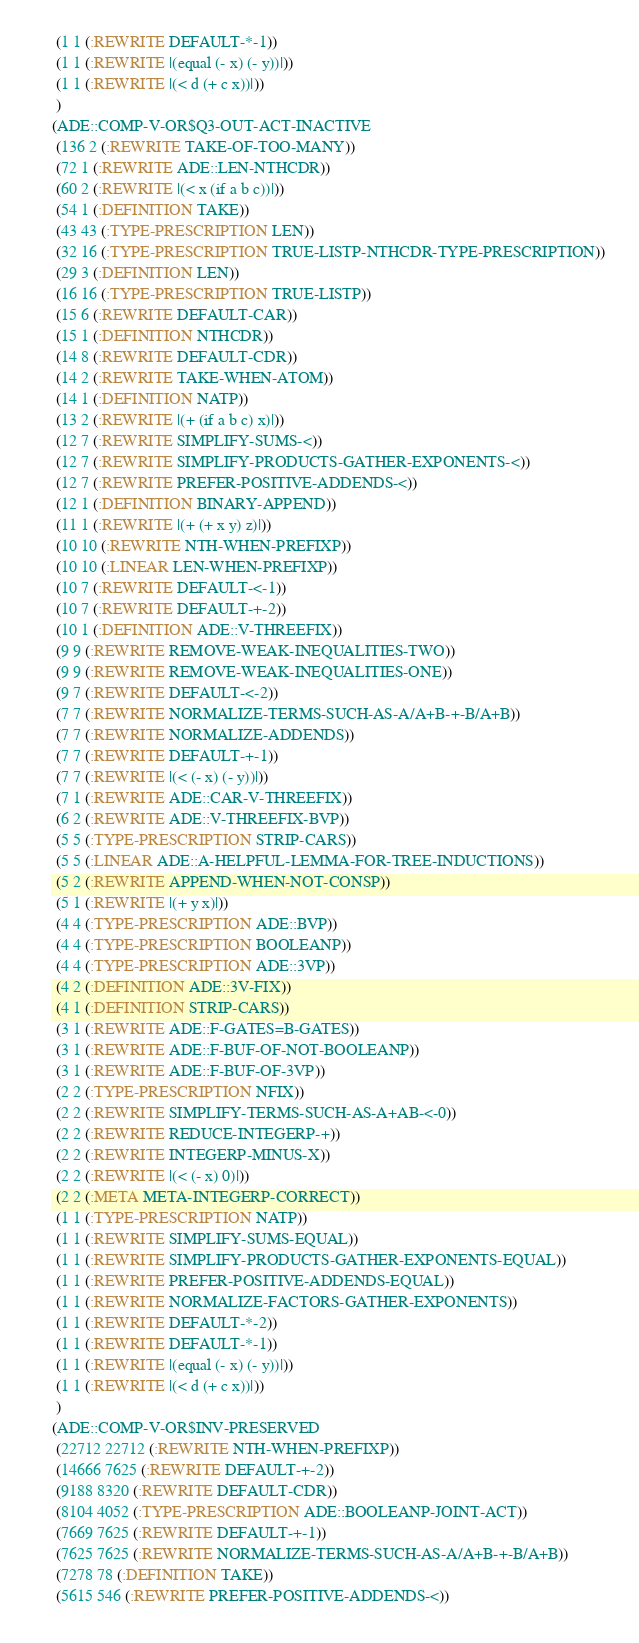<code> <loc_0><loc_0><loc_500><loc_500><_Lisp_> (1 1 (:REWRITE DEFAULT-*-1))
 (1 1 (:REWRITE |(equal (- x) (- y))|))
 (1 1 (:REWRITE |(< d (+ c x))|))
 )
(ADE::COMP-V-OR$Q3-OUT-ACT-INACTIVE
 (136 2 (:REWRITE TAKE-OF-TOO-MANY))
 (72 1 (:REWRITE ADE::LEN-NTHCDR))
 (60 2 (:REWRITE |(< x (if a b c))|))
 (54 1 (:DEFINITION TAKE))
 (43 43 (:TYPE-PRESCRIPTION LEN))
 (32 16 (:TYPE-PRESCRIPTION TRUE-LISTP-NTHCDR-TYPE-PRESCRIPTION))
 (29 3 (:DEFINITION LEN))
 (16 16 (:TYPE-PRESCRIPTION TRUE-LISTP))
 (15 6 (:REWRITE DEFAULT-CAR))
 (15 1 (:DEFINITION NTHCDR))
 (14 8 (:REWRITE DEFAULT-CDR))
 (14 2 (:REWRITE TAKE-WHEN-ATOM))
 (14 1 (:DEFINITION NATP))
 (13 2 (:REWRITE |(+ (if a b c) x)|))
 (12 7 (:REWRITE SIMPLIFY-SUMS-<))
 (12 7 (:REWRITE SIMPLIFY-PRODUCTS-GATHER-EXPONENTS-<))
 (12 7 (:REWRITE PREFER-POSITIVE-ADDENDS-<))
 (12 1 (:DEFINITION BINARY-APPEND))
 (11 1 (:REWRITE |(+ (+ x y) z)|))
 (10 10 (:REWRITE NTH-WHEN-PREFIXP))
 (10 10 (:LINEAR LEN-WHEN-PREFIXP))
 (10 7 (:REWRITE DEFAULT-<-1))
 (10 7 (:REWRITE DEFAULT-+-2))
 (10 1 (:DEFINITION ADE::V-THREEFIX))
 (9 9 (:REWRITE REMOVE-WEAK-INEQUALITIES-TWO))
 (9 9 (:REWRITE REMOVE-WEAK-INEQUALITIES-ONE))
 (9 7 (:REWRITE DEFAULT-<-2))
 (7 7 (:REWRITE NORMALIZE-TERMS-SUCH-AS-A/A+B-+-B/A+B))
 (7 7 (:REWRITE NORMALIZE-ADDENDS))
 (7 7 (:REWRITE DEFAULT-+-1))
 (7 7 (:REWRITE |(< (- x) (- y))|))
 (7 1 (:REWRITE ADE::CAR-V-THREEFIX))
 (6 2 (:REWRITE ADE::V-THREEFIX-BVP))
 (5 5 (:TYPE-PRESCRIPTION STRIP-CARS))
 (5 5 (:LINEAR ADE::A-HELPFUL-LEMMA-FOR-TREE-INDUCTIONS))
 (5 2 (:REWRITE APPEND-WHEN-NOT-CONSP))
 (5 1 (:REWRITE |(+ y x)|))
 (4 4 (:TYPE-PRESCRIPTION ADE::BVP))
 (4 4 (:TYPE-PRESCRIPTION BOOLEANP))
 (4 4 (:TYPE-PRESCRIPTION ADE::3VP))
 (4 2 (:DEFINITION ADE::3V-FIX))
 (4 1 (:DEFINITION STRIP-CARS))
 (3 1 (:REWRITE ADE::F-GATES=B-GATES))
 (3 1 (:REWRITE ADE::F-BUF-OF-NOT-BOOLEANP))
 (3 1 (:REWRITE ADE::F-BUF-OF-3VP))
 (2 2 (:TYPE-PRESCRIPTION NFIX))
 (2 2 (:REWRITE SIMPLIFY-TERMS-SUCH-AS-A+AB-<-0))
 (2 2 (:REWRITE REDUCE-INTEGERP-+))
 (2 2 (:REWRITE INTEGERP-MINUS-X))
 (2 2 (:REWRITE |(< (- x) 0)|))
 (2 2 (:META META-INTEGERP-CORRECT))
 (1 1 (:TYPE-PRESCRIPTION NATP))
 (1 1 (:REWRITE SIMPLIFY-SUMS-EQUAL))
 (1 1 (:REWRITE SIMPLIFY-PRODUCTS-GATHER-EXPONENTS-EQUAL))
 (1 1 (:REWRITE PREFER-POSITIVE-ADDENDS-EQUAL))
 (1 1 (:REWRITE NORMALIZE-FACTORS-GATHER-EXPONENTS))
 (1 1 (:REWRITE DEFAULT-*-2))
 (1 1 (:REWRITE DEFAULT-*-1))
 (1 1 (:REWRITE |(equal (- x) (- y))|))
 (1 1 (:REWRITE |(< d (+ c x))|))
 )
(ADE::COMP-V-OR$INV-PRESERVED
 (22712 22712 (:REWRITE NTH-WHEN-PREFIXP))
 (14666 7625 (:REWRITE DEFAULT-+-2))
 (9188 8320 (:REWRITE DEFAULT-CDR))
 (8104 4052 (:TYPE-PRESCRIPTION ADE::BOOLEANP-JOINT-ACT))
 (7669 7625 (:REWRITE DEFAULT-+-1))
 (7625 7625 (:REWRITE NORMALIZE-TERMS-SUCH-AS-A/A+B-+-B/A+B))
 (7278 78 (:DEFINITION TAKE))
 (5615 546 (:REWRITE PREFER-POSITIVE-ADDENDS-<))</code> 